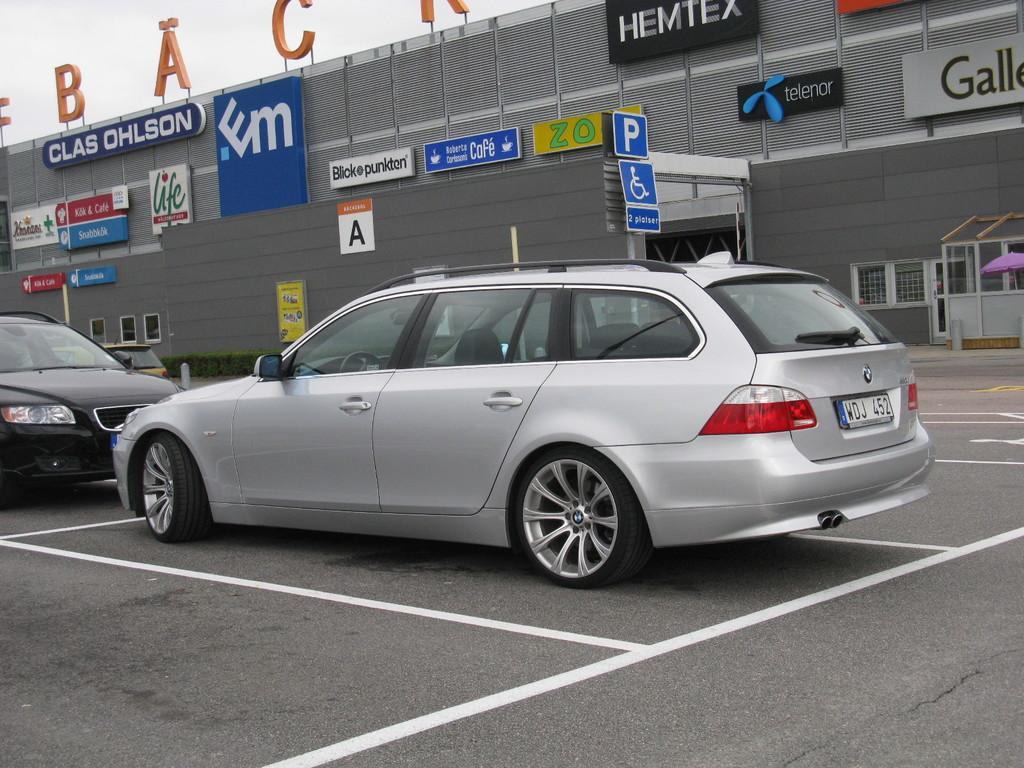<image>
Share a concise interpretation of the image provided. A few cars outside a building with a sign on it that says Clas Ohlson. 